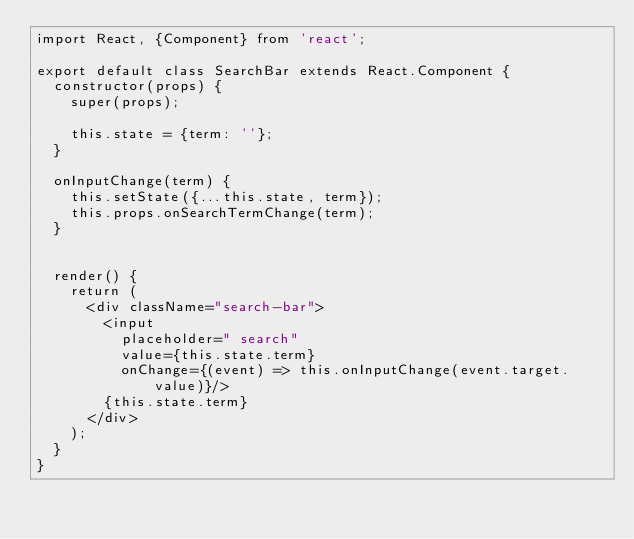Convert code to text. <code><loc_0><loc_0><loc_500><loc_500><_JavaScript_>import React, {Component} from 'react';

export default class SearchBar extends React.Component {
  constructor(props) {
    super(props);

    this.state = {term: ''};
  }

  onInputChange(term) {
    this.setState({...this.state, term});
    this.props.onSearchTermChange(term);
  }


  render() {
    return (
      <div className="search-bar">
        <input
          placeholder=" search"
          value={this.state.term}
          onChange={(event) => this.onInputChange(event.target.value)}/>
        {this.state.term}
      </div>
    );
  }
}
</code> 